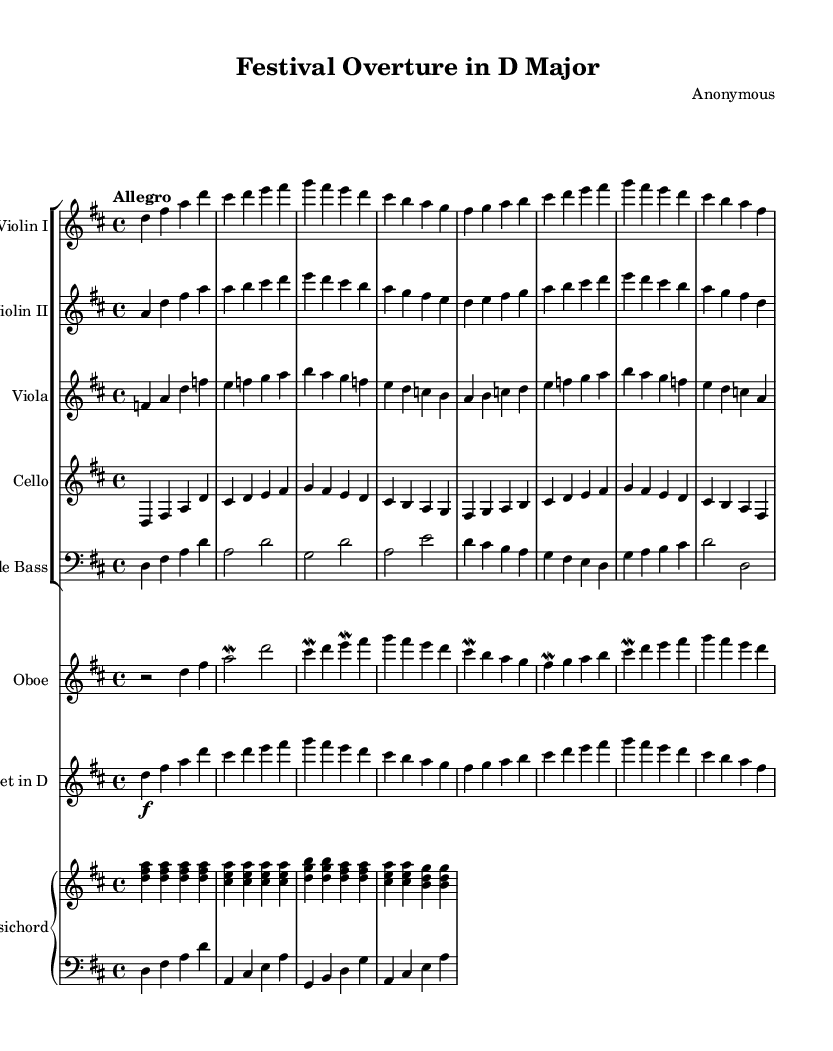What is the key signature of this music? The key signature is indicated at the beginning of the sheet music where it shows two sharps, which means it is in D major.
Answer: D major What is the time signature of this piece? The time signature is located at the start of the sheet music, which shows that this piece is written in a 4/4 meter, indicating four beats in each measure.
Answer: 4/4 What is the tempo marking for this composition? The tempo marking is explicitly stated in the score, indicating "Allegro" which means to play at a fast, lively tempo.
Answer: Allegro How many parts are in this score? By examining the score, we count the number of distinct staves in the score which totals to six parts, including strings, woodwinds, and keyboard.
Answer: Six Which instruments are used in this piece? Looking at the individual staves labeled at the beginning of each section, we can identify the instruments as Violin I, Violin II, Viola, Cello, Double Bass, Oboe, Trumpet in D, and Harpsichord.
Answer: Violin I, Violin II, Viola, Cello, Double Bass, Oboe, Trumpet in D, Harpsichord How does the harmony in Baroque music typically support the melody? In Baroque music, harmony often involves the use of figured bass with chords that enrich the melodic structure; in this case, the harpsichord provides harmonic support under the orchestral melody.
Answer: Figured bass 